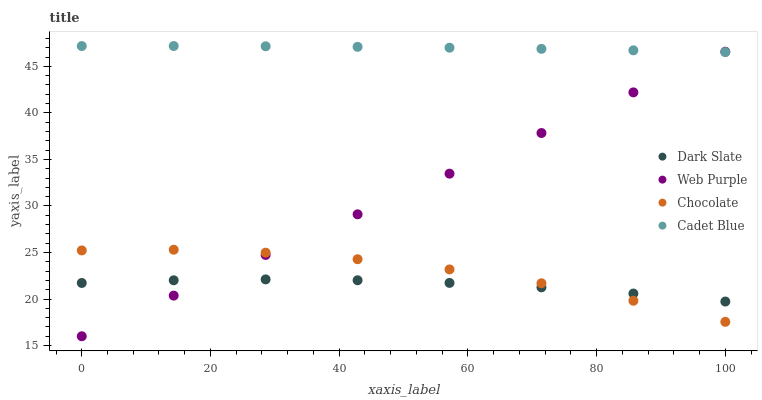Does Dark Slate have the minimum area under the curve?
Answer yes or no. Yes. Does Cadet Blue have the maximum area under the curve?
Answer yes or no. Yes. Does Web Purple have the minimum area under the curve?
Answer yes or no. No. Does Web Purple have the maximum area under the curve?
Answer yes or no. No. Is Web Purple the smoothest?
Answer yes or no. Yes. Is Chocolate the roughest?
Answer yes or no. Yes. Is Cadet Blue the smoothest?
Answer yes or no. No. Is Cadet Blue the roughest?
Answer yes or no. No. Does Web Purple have the lowest value?
Answer yes or no. Yes. Does Cadet Blue have the lowest value?
Answer yes or no. No. Does Cadet Blue have the highest value?
Answer yes or no. Yes. Does Web Purple have the highest value?
Answer yes or no. No. Is Dark Slate less than Cadet Blue?
Answer yes or no. Yes. Is Cadet Blue greater than Chocolate?
Answer yes or no. Yes. Does Web Purple intersect Cadet Blue?
Answer yes or no. Yes. Is Web Purple less than Cadet Blue?
Answer yes or no. No. Is Web Purple greater than Cadet Blue?
Answer yes or no. No. Does Dark Slate intersect Cadet Blue?
Answer yes or no. No. 